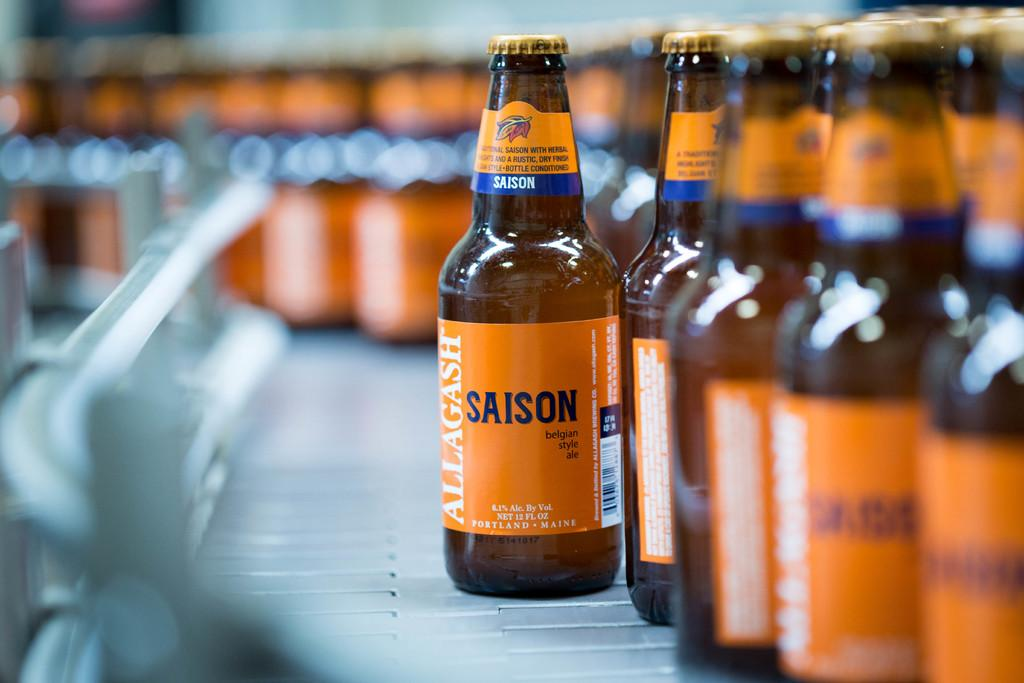<image>
Present a compact description of the photo's key features. Many bottles of Allagash Saison sit on an assembly line. 